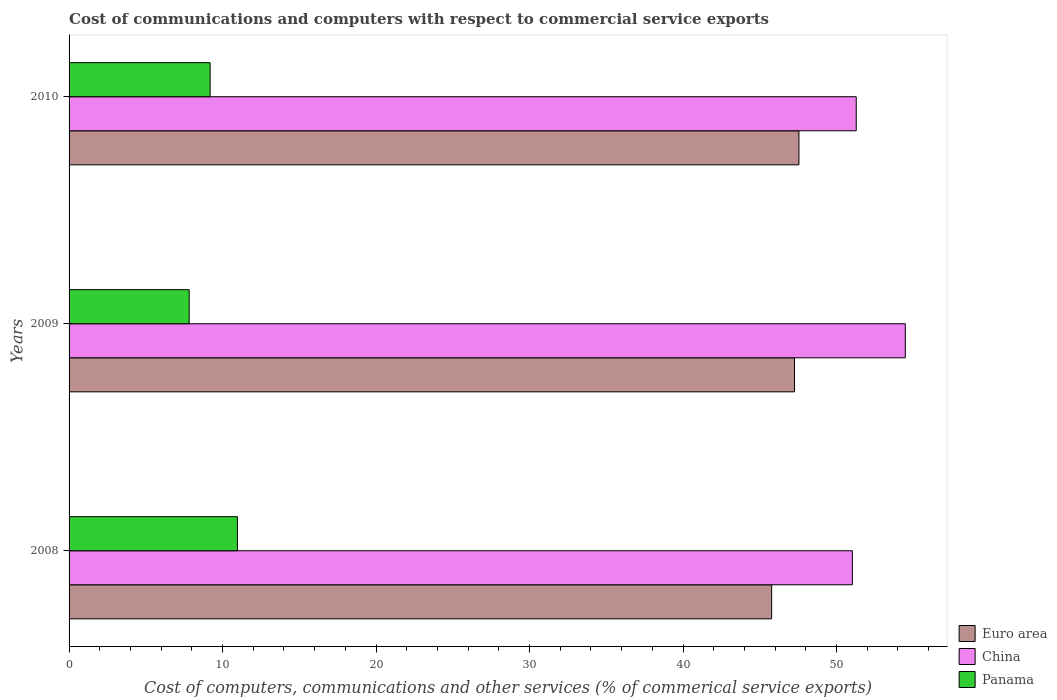How many groups of bars are there?
Offer a very short reply. 3. Are the number of bars per tick equal to the number of legend labels?
Offer a terse response. Yes. How many bars are there on the 2nd tick from the bottom?
Your answer should be very brief. 3. What is the label of the 3rd group of bars from the top?
Your answer should be compact. 2008. In how many cases, is the number of bars for a given year not equal to the number of legend labels?
Your answer should be very brief. 0. What is the cost of communications and computers in Panama in 2008?
Provide a short and direct response. 10.97. Across all years, what is the maximum cost of communications and computers in Euro area?
Provide a short and direct response. 47.55. Across all years, what is the minimum cost of communications and computers in Euro area?
Your answer should be very brief. 45.77. In which year was the cost of communications and computers in Panama maximum?
Give a very brief answer. 2008. What is the total cost of communications and computers in Euro area in the graph?
Provide a short and direct response. 140.58. What is the difference between the cost of communications and computers in Euro area in 2009 and that in 2010?
Provide a short and direct response. -0.29. What is the difference between the cost of communications and computers in China in 2010 and the cost of communications and computers in Panama in 2009?
Keep it short and to the point. 43.46. What is the average cost of communications and computers in Panama per year?
Your response must be concise. 9.33. In the year 2008, what is the difference between the cost of communications and computers in China and cost of communications and computers in Panama?
Provide a short and direct response. 40.06. What is the ratio of the cost of communications and computers in Euro area in 2008 to that in 2009?
Provide a short and direct response. 0.97. What is the difference between the highest and the second highest cost of communications and computers in Euro area?
Keep it short and to the point. 0.29. What is the difference between the highest and the lowest cost of communications and computers in Euro area?
Offer a terse response. 1.78. In how many years, is the cost of communications and computers in Euro area greater than the average cost of communications and computers in Euro area taken over all years?
Offer a terse response. 2. What does the 1st bar from the top in 2010 represents?
Offer a very short reply. Panama. Is it the case that in every year, the sum of the cost of communications and computers in Euro area and cost of communications and computers in Panama is greater than the cost of communications and computers in China?
Provide a short and direct response. Yes. How many years are there in the graph?
Your answer should be very brief. 3. Does the graph contain any zero values?
Make the answer very short. No. Does the graph contain grids?
Your response must be concise. No. Where does the legend appear in the graph?
Ensure brevity in your answer.  Bottom right. What is the title of the graph?
Give a very brief answer. Cost of communications and computers with respect to commercial service exports. Does "Latvia" appear as one of the legend labels in the graph?
Provide a short and direct response. No. What is the label or title of the X-axis?
Your response must be concise. Cost of computers, communications and other services (% of commerical service exports). What is the Cost of computers, communications and other services (% of commerical service exports) in Euro area in 2008?
Ensure brevity in your answer.  45.77. What is the Cost of computers, communications and other services (% of commerical service exports) in China in 2008?
Offer a terse response. 51.03. What is the Cost of computers, communications and other services (% of commerical service exports) of Panama in 2008?
Keep it short and to the point. 10.97. What is the Cost of computers, communications and other services (% of commerical service exports) in Euro area in 2009?
Make the answer very short. 47.26. What is the Cost of computers, communications and other services (% of commerical service exports) of China in 2009?
Provide a short and direct response. 54.48. What is the Cost of computers, communications and other services (% of commerical service exports) of Panama in 2009?
Your answer should be very brief. 7.83. What is the Cost of computers, communications and other services (% of commerical service exports) in Euro area in 2010?
Give a very brief answer. 47.55. What is the Cost of computers, communications and other services (% of commerical service exports) in China in 2010?
Give a very brief answer. 51.28. What is the Cost of computers, communications and other services (% of commerical service exports) of Panama in 2010?
Your response must be concise. 9.19. Across all years, what is the maximum Cost of computers, communications and other services (% of commerical service exports) of Euro area?
Give a very brief answer. 47.55. Across all years, what is the maximum Cost of computers, communications and other services (% of commerical service exports) of China?
Offer a very short reply. 54.48. Across all years, what is the maximum Cost of computers, communications and other services (% of commerical service exports) in Panama?
Keep it short and to the point. 10.97. Across all years, what is the minimum Cost of computers, communications and other services (% of commerical service exports) in Euro area?
Offer a terse response. 45.77. Across all years, what is the minimum Cost of computers, communications and other services (% of commerical service exports) of China?
Keep it short and to the point. 51.03. Across all years, what is the minimum Cost of computers, communications and other services (% of commerical service exports) of Panama?
Give a very brief answer. 7.83. What is the total Cost of computers, communications and other services (% of commerical service exports) of Euro area in the graph?
Provide a short and direct response. 140.58. What is the total Cost of computers, communications and other services (% of commerical service exports) in China in the graph?
Keep it short and to the point. 156.79. What is the total Cost of computers, communications and other services (% of commerical service exports) of Panama in the graph?
Provide a succinct answer. 27.98. What is the difference between the Cost of computers, communications and other services (% of commerical service exports) of Euro area in 2008 and that in 2009?
Provide a short and direct response. -1.49. What is the difference between the Cost of computers, communications and other services (% of commerical service exports) in China in 2008 and that in 2009?
Offer a very short reply. -3.45. What is the difference between the Cost of computers, communications and other services (% of commerical service exports) in Panama in 2008 and that in 2009?
Offer a very short reply. 3.14. What is the difference between the Cost of computers, communications and other services (% of commerical service exports) of Euro area in 2008 and that in 2010?
Your answer should be compact. -1.78. What is the difference between the Cost of computers, communications and other services (% of commerical service exports) of China in 2008 and that in 2010?
Make the answer very short. -0.25. What is the difference between the Cost of computers, communications and other services (% of commerical service exports) of Panama in 2008 and that in 2010?
Give a very brief answer. 1.78. What is the difference between the Cost of computers, communications and other services (% of commerical service exports) of Euro area in 2009 and that in 2010?
Offer a very short reply. -0.29. What is the difference between the Cost of computers, communications and other services (% of commerical service exports) of China in 2009 and that in 2010?
Give a very brief answer. 3.2. What is the difference between the Cost of computers, communications and other services (% of commerical service exports) in Panama in 2009 and that in 2010?
Provide a short and direct response. -1.36. What is the difference between the Cost of computers, communications and other services (% of commerical service exports) in Euro area in 2008 and the Cost of computers, communications and other services (% of commerical service exports) in China in 2009?
Give a very brief answer. -8.71. What is the difference between the Cost of computers, communications and other services (% of commerical service exports) in Euro area in 2008 and the Cost of computers, communications and other services (% of commerical service exports) in Panama in 2009?
Make the answer very short. 37.95. What is the difference between the Cost of computers, communications and other services (% of commerical service exports) in China in 2008 and the Cost of computers, communications and other services (% of commerical service exports) in Panama in 2009?
Your response must be concise. 43.21. What is the difference between the Cost of computers, communications and other services (% of commerical service exports) of Euro area in 2008 and the Cost of computers, communications and other services (% of commerical service exports) of China in 2010?
Your response must be concise. -5.51. What is the difference between the Cost of computers, communications and other services (% of commerical service exports) in Euro area in 2008 and the Cost of computers, communications and other services (% of commerical service exports) in Panama in 2010?
Make the answer very short. 36.58. What is the difference between the Cost of computers, communications and other services (% of commerical service exports) in China in 2008 and the Cost of computers, communications and other services (% of commerical service exports) in Panama in 2010?
Give a very brief answer. 41.84. What is the difference between the Cost of computers, communications and other services (% of commerical service exports) of Euro area in 2009 and the Cost of computers, communications and other services (% of commerical service exports) of China in 2010?
Your answer should be compact. -4.02. What is the difference between the Cost of computers, communications and other services (% of commerical service exports) of Euro area in 2009 and the Cost of computers, communications and other services (% of commerical service exports) of Panama in 2010?
Keep it short and to the point. 38.07. What is the difference between the Cost of computers, communications and other services (% of commerical service exports) in China in 2009 and the Cost of computers, communications and other services (% of commerical service exports) in Panama in 2010?
Your answer should be very brief. 45.29. What is the average Cost of computers, communications and other services (% of commerical service exports) in Euro area per year?
Your response must be concise. 46.86. What is the average Cost of computers, communications and other services (% of commerical service exports) of China per year?
Provide a short and direct response. 52.26. What is the average Cost of computers, communications and other services (% of commerical service exports) of Panama per year?
Offer a very short reply. 9.33. In the year 2008, what is the difference between the Cost of computers, communications and other services (% of commerical service exports) of Euro area and Cost of computers, communications and other services (% of commerical service exports) of China?
Offer a very short reply. -5.26. In the year 2008, what is the difference between the Cost of computers, communications and other services (% of commerical service exports) of Euro area and Cost of computers, communications and other services (% of commerical service exports) of Panama?
Provide a short and direct response. 34.8. In the year 2008, what is the difference between the Cost of computers, communications and other services (% of commerical service exports) in China and Cost of computers, communications and other services (% of commerical service exports) in Panama?
Your answer should be very brief. 40.06. In the year 2009, what is the difference between the Cost of computers, communications and other services (% of commerical service exports) of Euro area and Cost of computers, communications and other services (% of commerical service exports) of China?
Your answer should be compact. -7.22. In the year 2009, what is the difference between the Cost of computers, communications and other services (% of commerical service exports) of Euro area and Cost of computers, communications and other services (% of commerical service exports) of Panama?
Offer a terse response. 39.44. In the year 2009, what is the difference between the Cost of computers, communications and other services (% of commerical service exports) in China and Cost of computers, communications and other services (% of commerical service exports) in Panama?
Keep it short and to the point. 46.65. In the year 2010, what is the difference between the Cost of computers, communications and other services (% of commerical service exports) of Euro area and Cost of computers, communications and other services (% of commerical service exports) of China?
Ensure brevity in your answer.  -3.73. In the year 2010, what is the difference between the Cost of computers, communications and other services (% of commerical service exports) in Euro area and Cost of computers, communications and other services (% of commerical service exports) in Panama?
Offer a very short reply. 38.36. In the year 2010, what is the difference between the Cost of computers, communications and other services (% of commerical service exports) of China and Cost of computers, communications and other services (% of commerical service exports) of Panama?
Provide a succinct answer. 42.09. What is the ratio of the Cost of computers, communications and other services (% of commerical service exports) of Euro area in 2008 to that in 2009?
Ensure brevity in your answer.  0.97. What is the ratio of the Cost of computers, communications and other services (% of commerical service exports) in China in 2008 to that in 2009?
Offer a very short reply. 0.94. What is the ratio of the Cost of computers, communications and other services (% of commerical service exports) of Panama in 2008 to that in 2009?
Keep it short and to the point. 1.4. What is the ratio of the Cost of computers, communications and other services (% of commerical service exports) in Euro area in 2008 to that in 2010?
Your response must be concise. 0.96. What is the ratio of the Cost of computers, communications and other services (% of commerical service exports) in China in 2008 to that in 2010?
Keep it short and to the point. 1. What is the ratio of the Cost of computers, communications and other services (% of commerical service exports) in Panama in 2008 to that in 2010?
Your answer should be very brief. 1.19. What is the ratio of the Cost of computers, communications and other services (% of commerical service exports) of Euro area in 2009 to that in 2010?
Keep it short and to the point. 0.99. What is the ratio of the Cost of computers, communications and other services (% of commerical service exports) of China in 2009 to that in 2010?
Make the answer very short. 1.06. What is the ratio of the Cost of computers, communications and other services (% of commerical service exports) of Panama in 2009 to that in 2010?
Keep it short and to the point. 0.85. What is the difference between the highest and the second highest Cost of computers, communications and other services (% of commerical service exports) of Euro area?
Make the answer very short. 0.29. What is the difference between the highest and the second highest Cost of computers, communications and other services (% of commerical service exports) in China?
Offer a terse response. 3.2. What is the difference between the highest and the second highest Cost of computers, communications and other services (% of commerical service exports) of Panama?
Your response must be concise. 1.78. What is the difference between the highest and the lowest Cost of computers, communications and other services (% of commerical service exports) of Euro area?
Your answer should be compact. 1.78. What is the difference between the highest and the lowest Cost of computers, communications and other services (% of commerical service exports) of China?
Provide a succinct answer. 3.45. What is the difference between the highest and the lowest Cost of computers, communications and other services (% of commerical service exports) of Panama?
Offer a terse response. 3.14. 